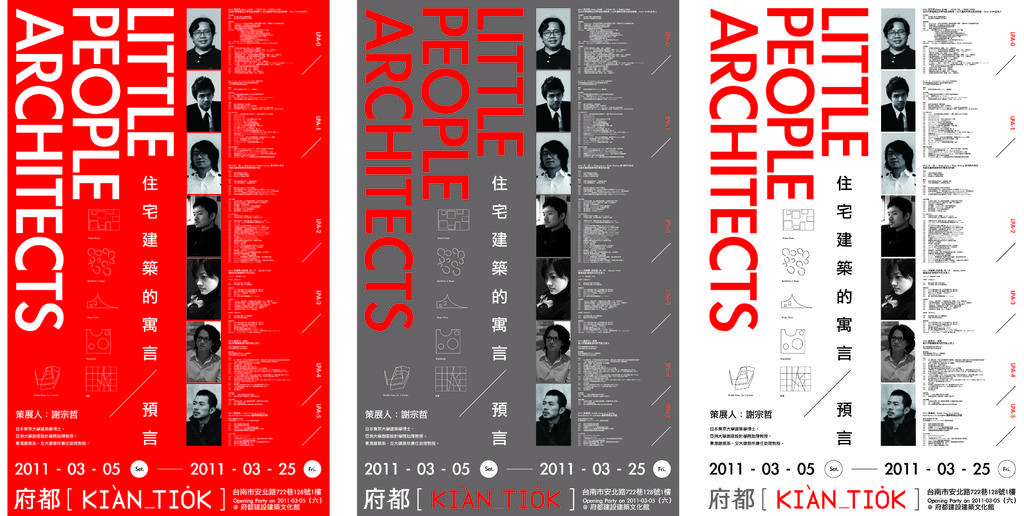What type of people are architects?
Offer a terse response. Little people. What kind of architects is this add for?
Make the answer very short. Little people. 